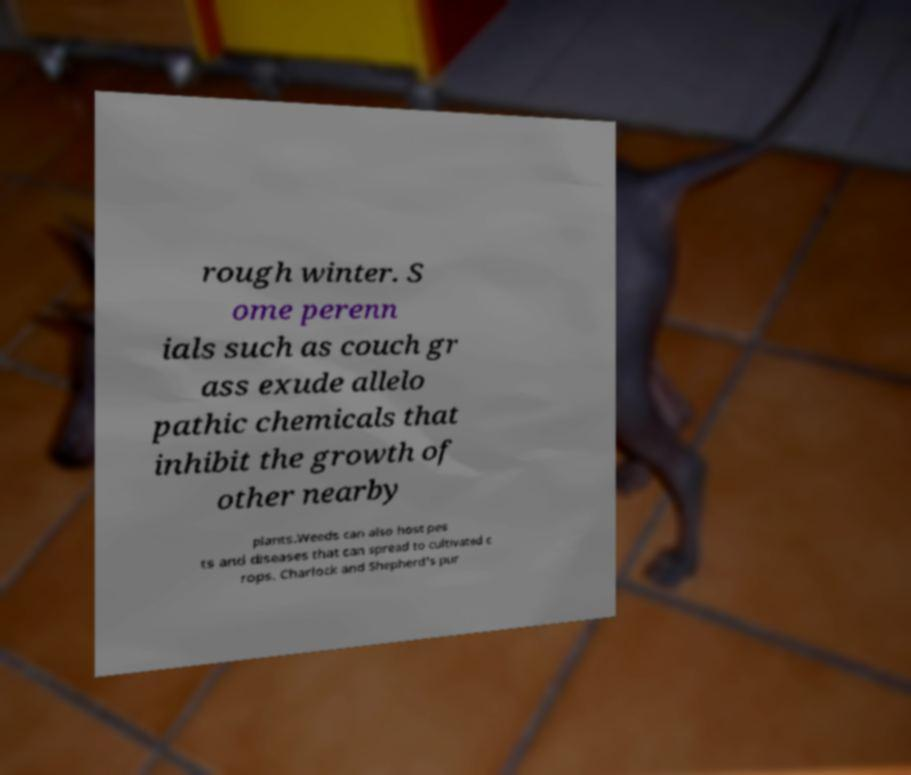Could you extract and type out the text from this image? rough winter. S ome perenn ials such as couch gr ass exude allelo pathic chemicals that inhibit the growth of other nearby plants.Weeds can also host pes ts and diseases that can spread to cultivated c rops. Charlock and Shepherd's pur 